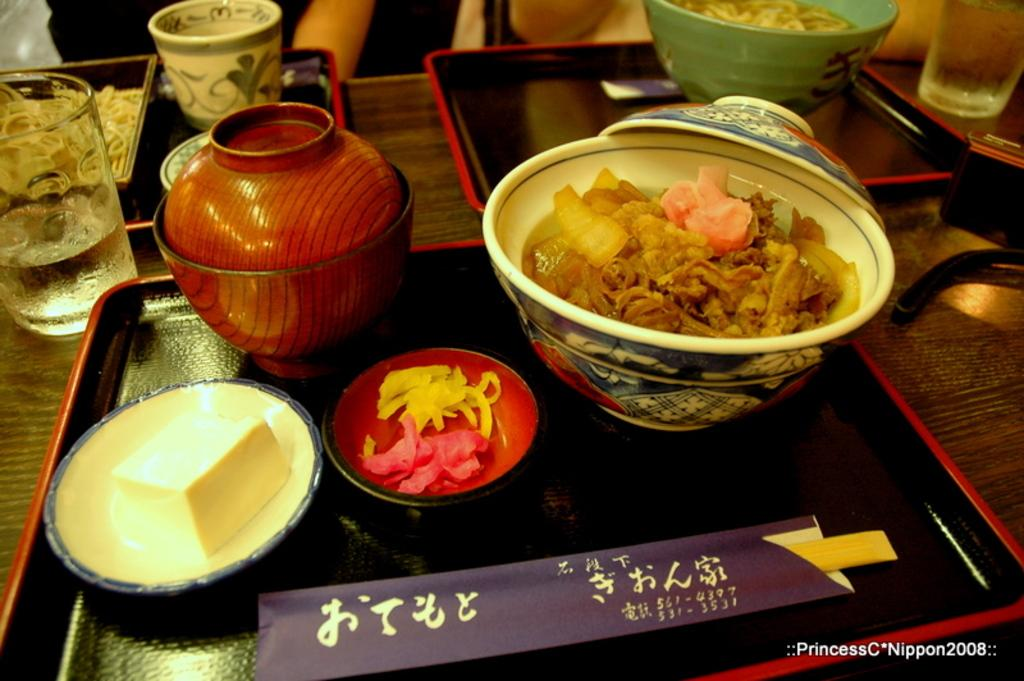What is located at the bottom of the image? There is a table at the bottom of the image. What items can be seen on the table? There are bowls, saucers, trays, cups, glasses, a pot, butter, and food placed on the table. Can you describe the types of containers on the table? There are bowls, saucers, trays, cups, and glasses on the table. What is the purpose of the butter on the table? The butter is likely used for spreading on food or as an ingredient in a dish. What type of food is placed on the table? The specific type of food is not mentioned, but it is present on the table. What type of needle is used to sew the tablecloth in the image? There is no needle or tablecloth present in the image; it only features a table with various items on it. 